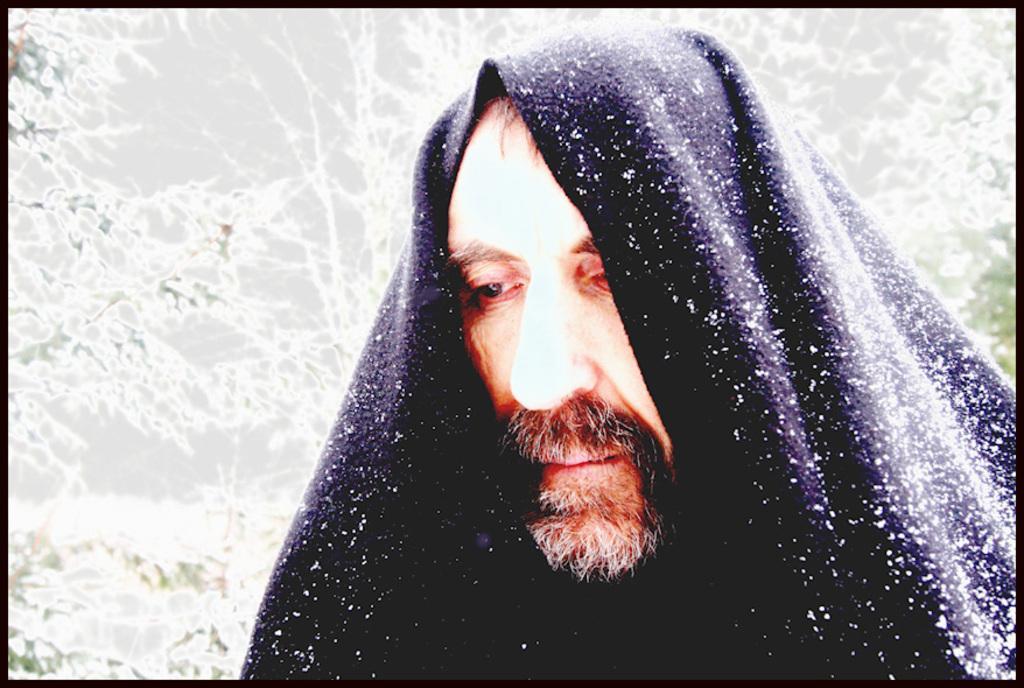In one or two sentences, can you explain what this image depicts? In this image, we can see a person covered with cloth. On the cloth, we can see the snow. Background there are few plants. Here we can see black color borders in the image. 